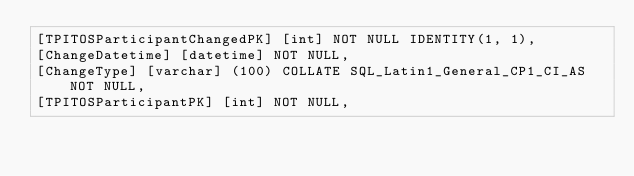Convert code to text. <code><loc_0><loc_0><loc_500><loc_500><_SQL_>[TPITOSParticipantChangedPK] [int] NOT NULL IDENTITY(1, 1),
[ChangeDatetime] [datetime] NOT NULL,
[ChangeType] [varchar] (100) COLLATE SQL_Latin1_General_CP1_CI_AS NOT NULL,
[TPITOSParticipantPK] [int] NOT NULL,</code> 